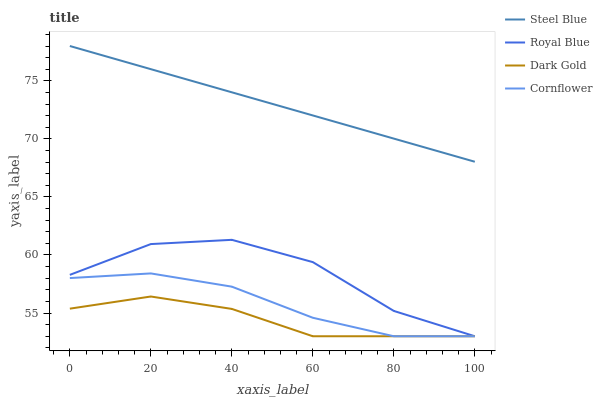Does Cornflower have the minimum area under the curve?
Answer yes or no. No. Does Cornflower have the maximum area under the curve?
Answer yes or no. No. Is Cornflower the smoothest?
Answer yes or no. No. Is Cornflower the roughest?
Answer yes or no. No. Does Steel Blue have the lowest value?
Answer yes or no. No. Does Cornflower have the highest value?
Answer yes or no. No. Is Cornflower less than Steel Blue?
Answer yes or no. Yes. Is Steel Blue greater than Cornflower?
Answer yes or no. Yes. Does Cornflower intersect Steel Blue?
Answer yes or no. No. 